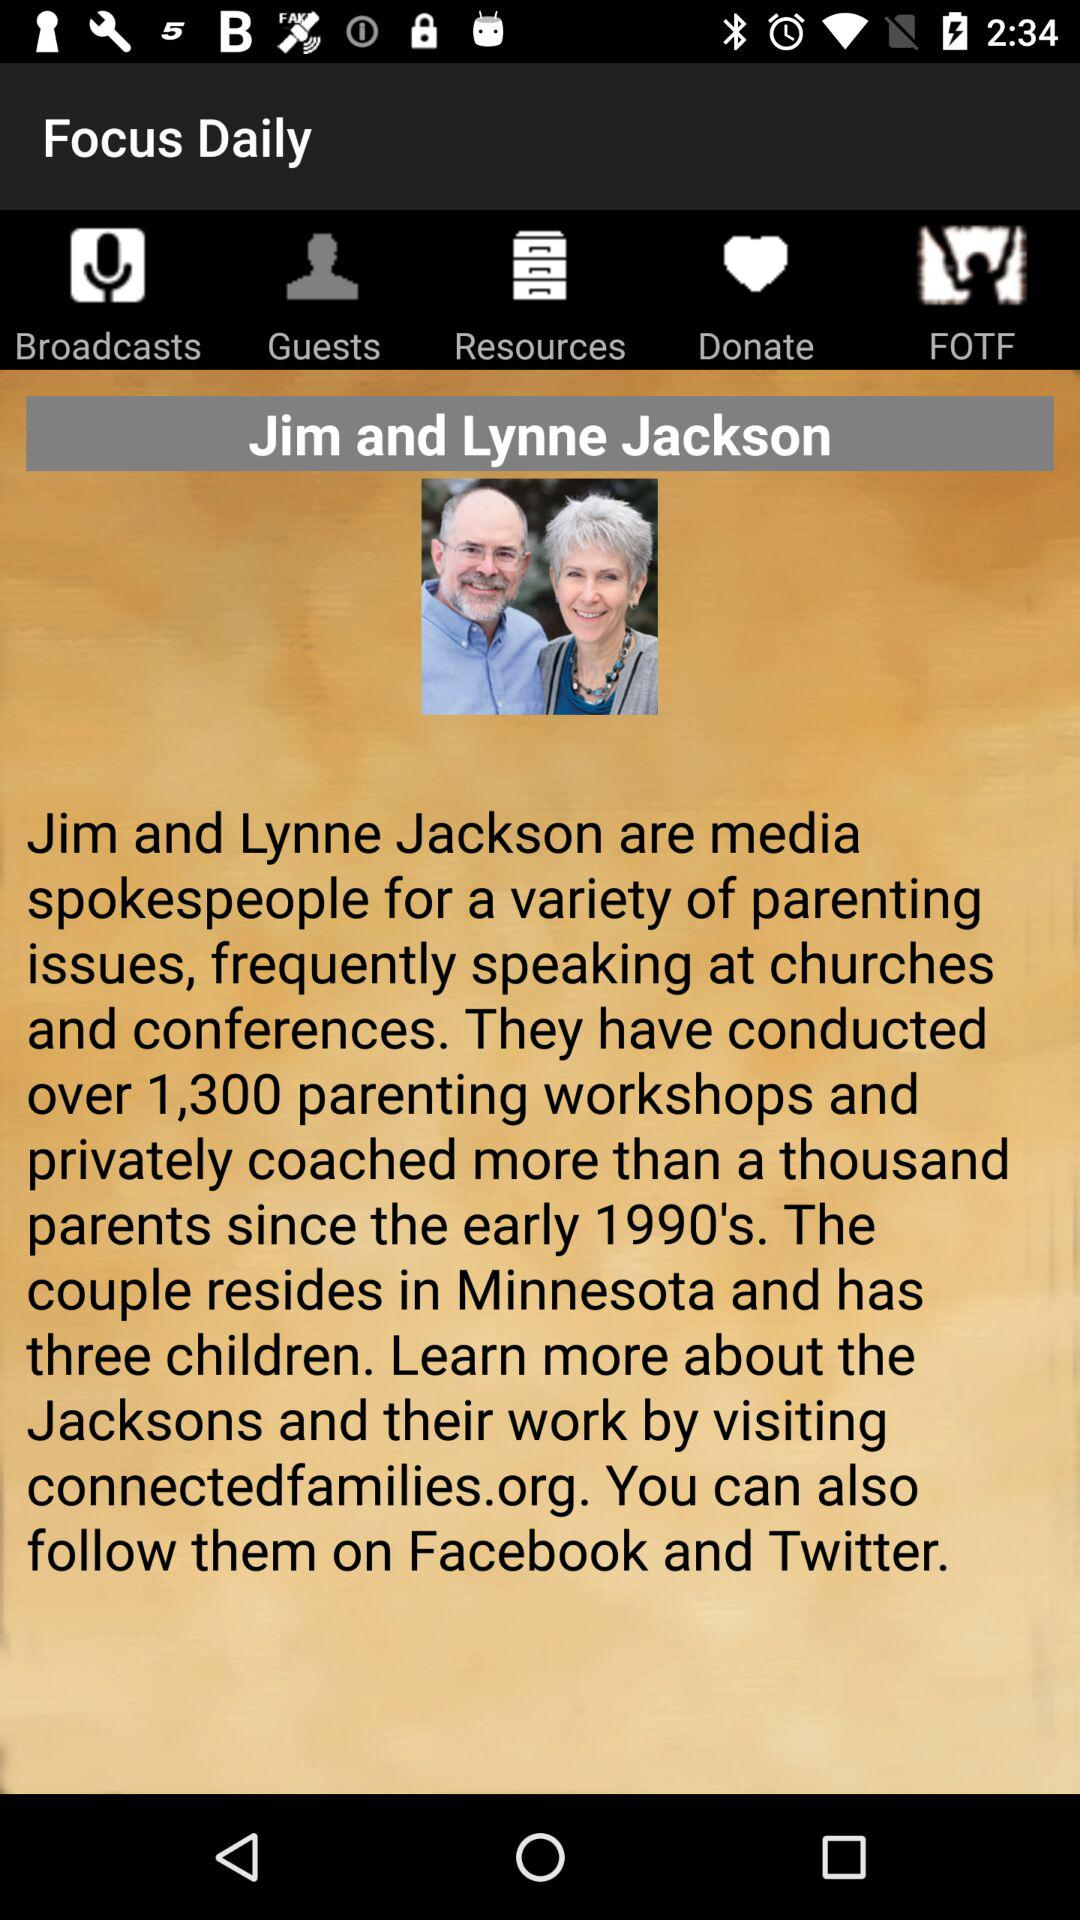How many workshops are there? There are 1,300 workshops. 